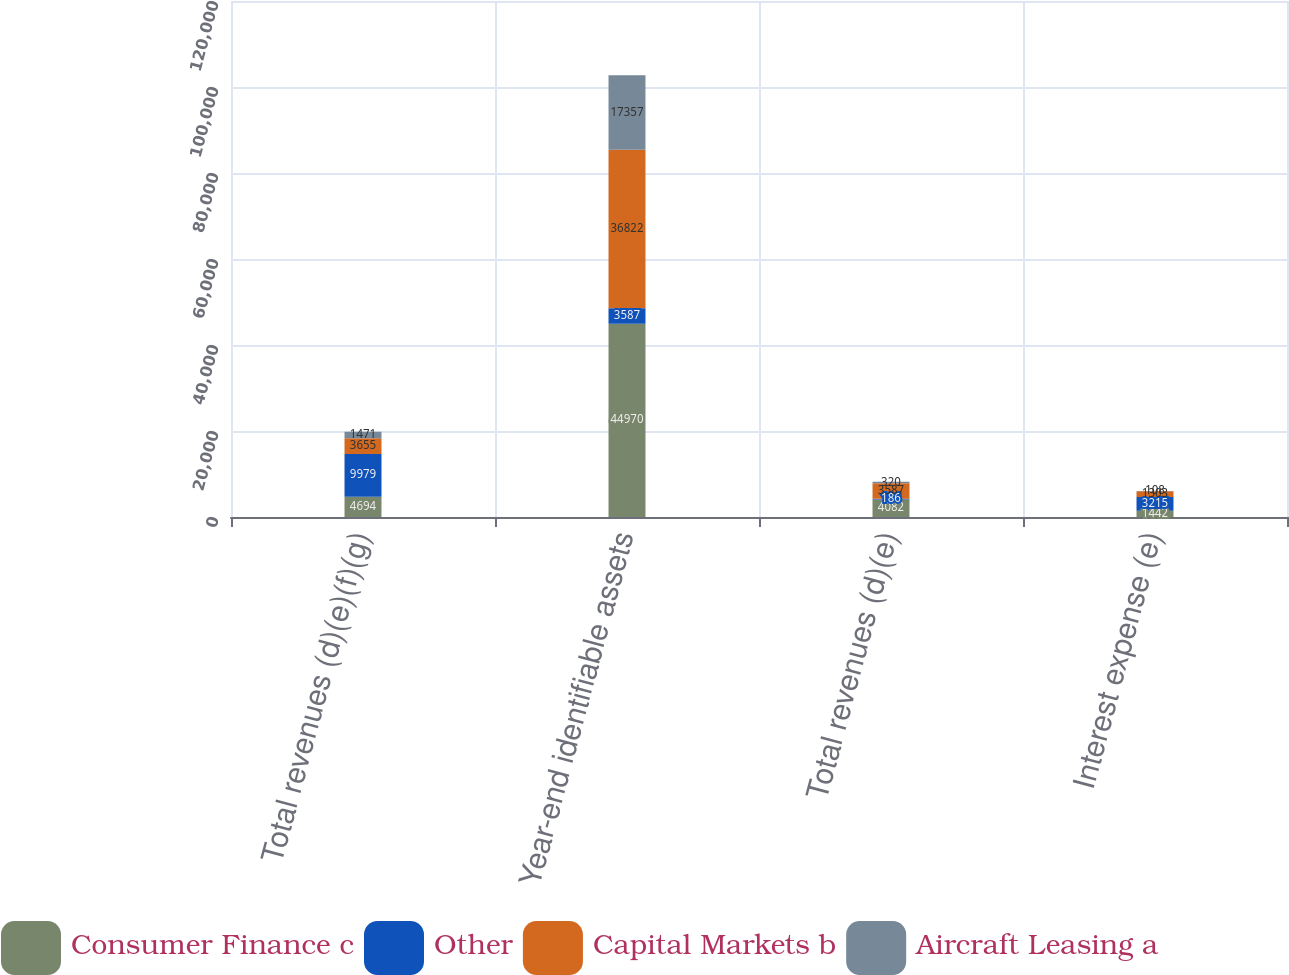<chart> <loc_0><loc_0><loc_500><loc_500><stacked_bar_chart><ecel><fcel>Total revenues (d)(e)(f)(g)<fcel>Year-end identifiable assets<fcel>Total revenues (d)(e)<fcel>Interest expense (e)<nl><fcel>Consumer Finance c<fcel>4694<fcel>44970<fcel>4082<fcel>1442<nl><fcel>Other<fcel>9979<fcel>3587<fcel>186<fcel>3215<nl><fcel>Capital Markets b<fcel>3655<fcel>36822<fcel>3587<fcel>1303<nl><fcel>Aircraft Leasing a<fcel>1471<fcel>17357<fcel>320<fcel>108<nl></chart> 